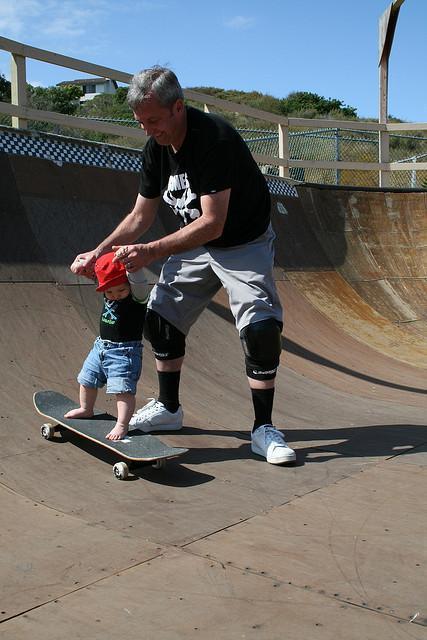How many people are in the photo?
Give a very brief answer. 2. 